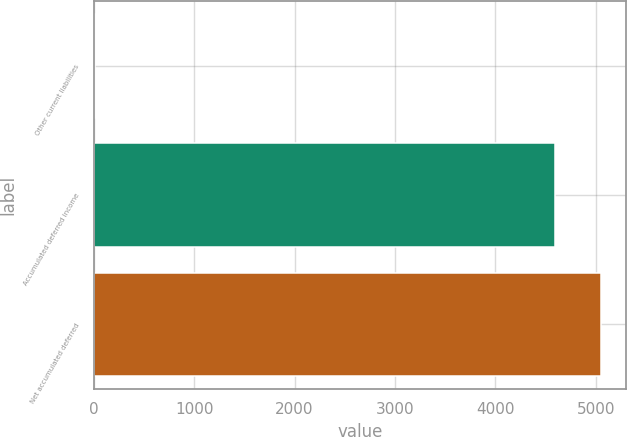<chart> <loc_0><loc_0><loc_500><loc_500><bar_chart><fcel>Other current liabilities<fcel>Accumulated deferred income<fcel>Net accumulated deferred<nl><fcel>10<fcel>4593<fcel>5052.3<nl></chart> 